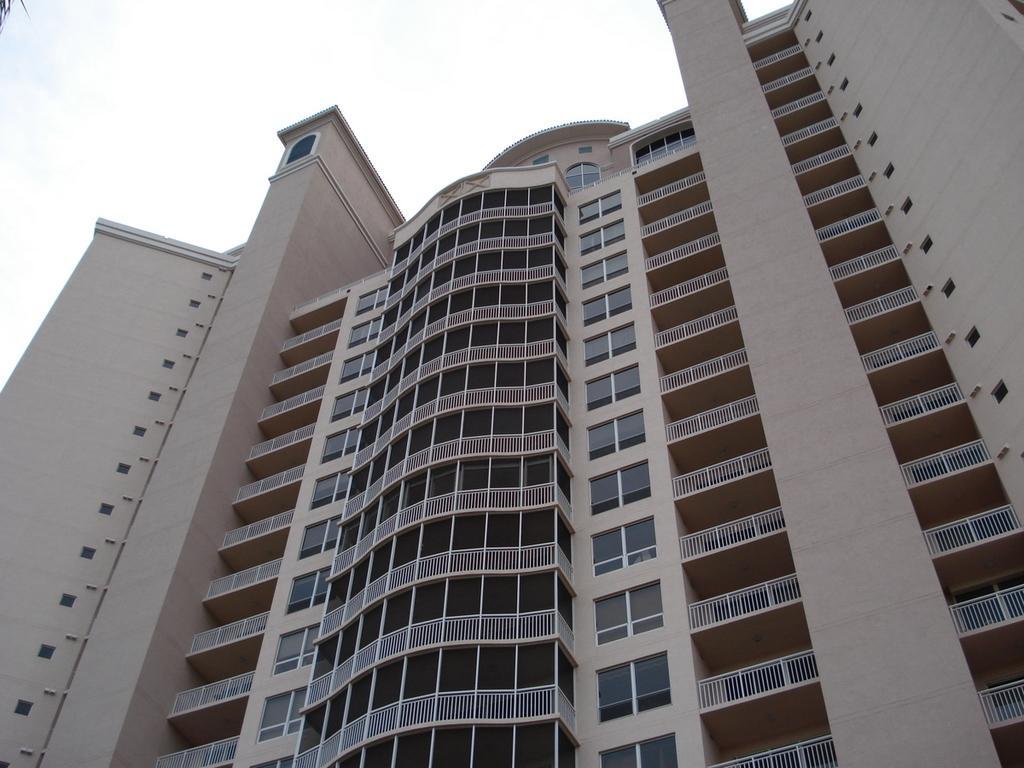Can you describe this image briefly? In the image there is building with walls, railings, windows and roofs. At the top of the image there is sky. 